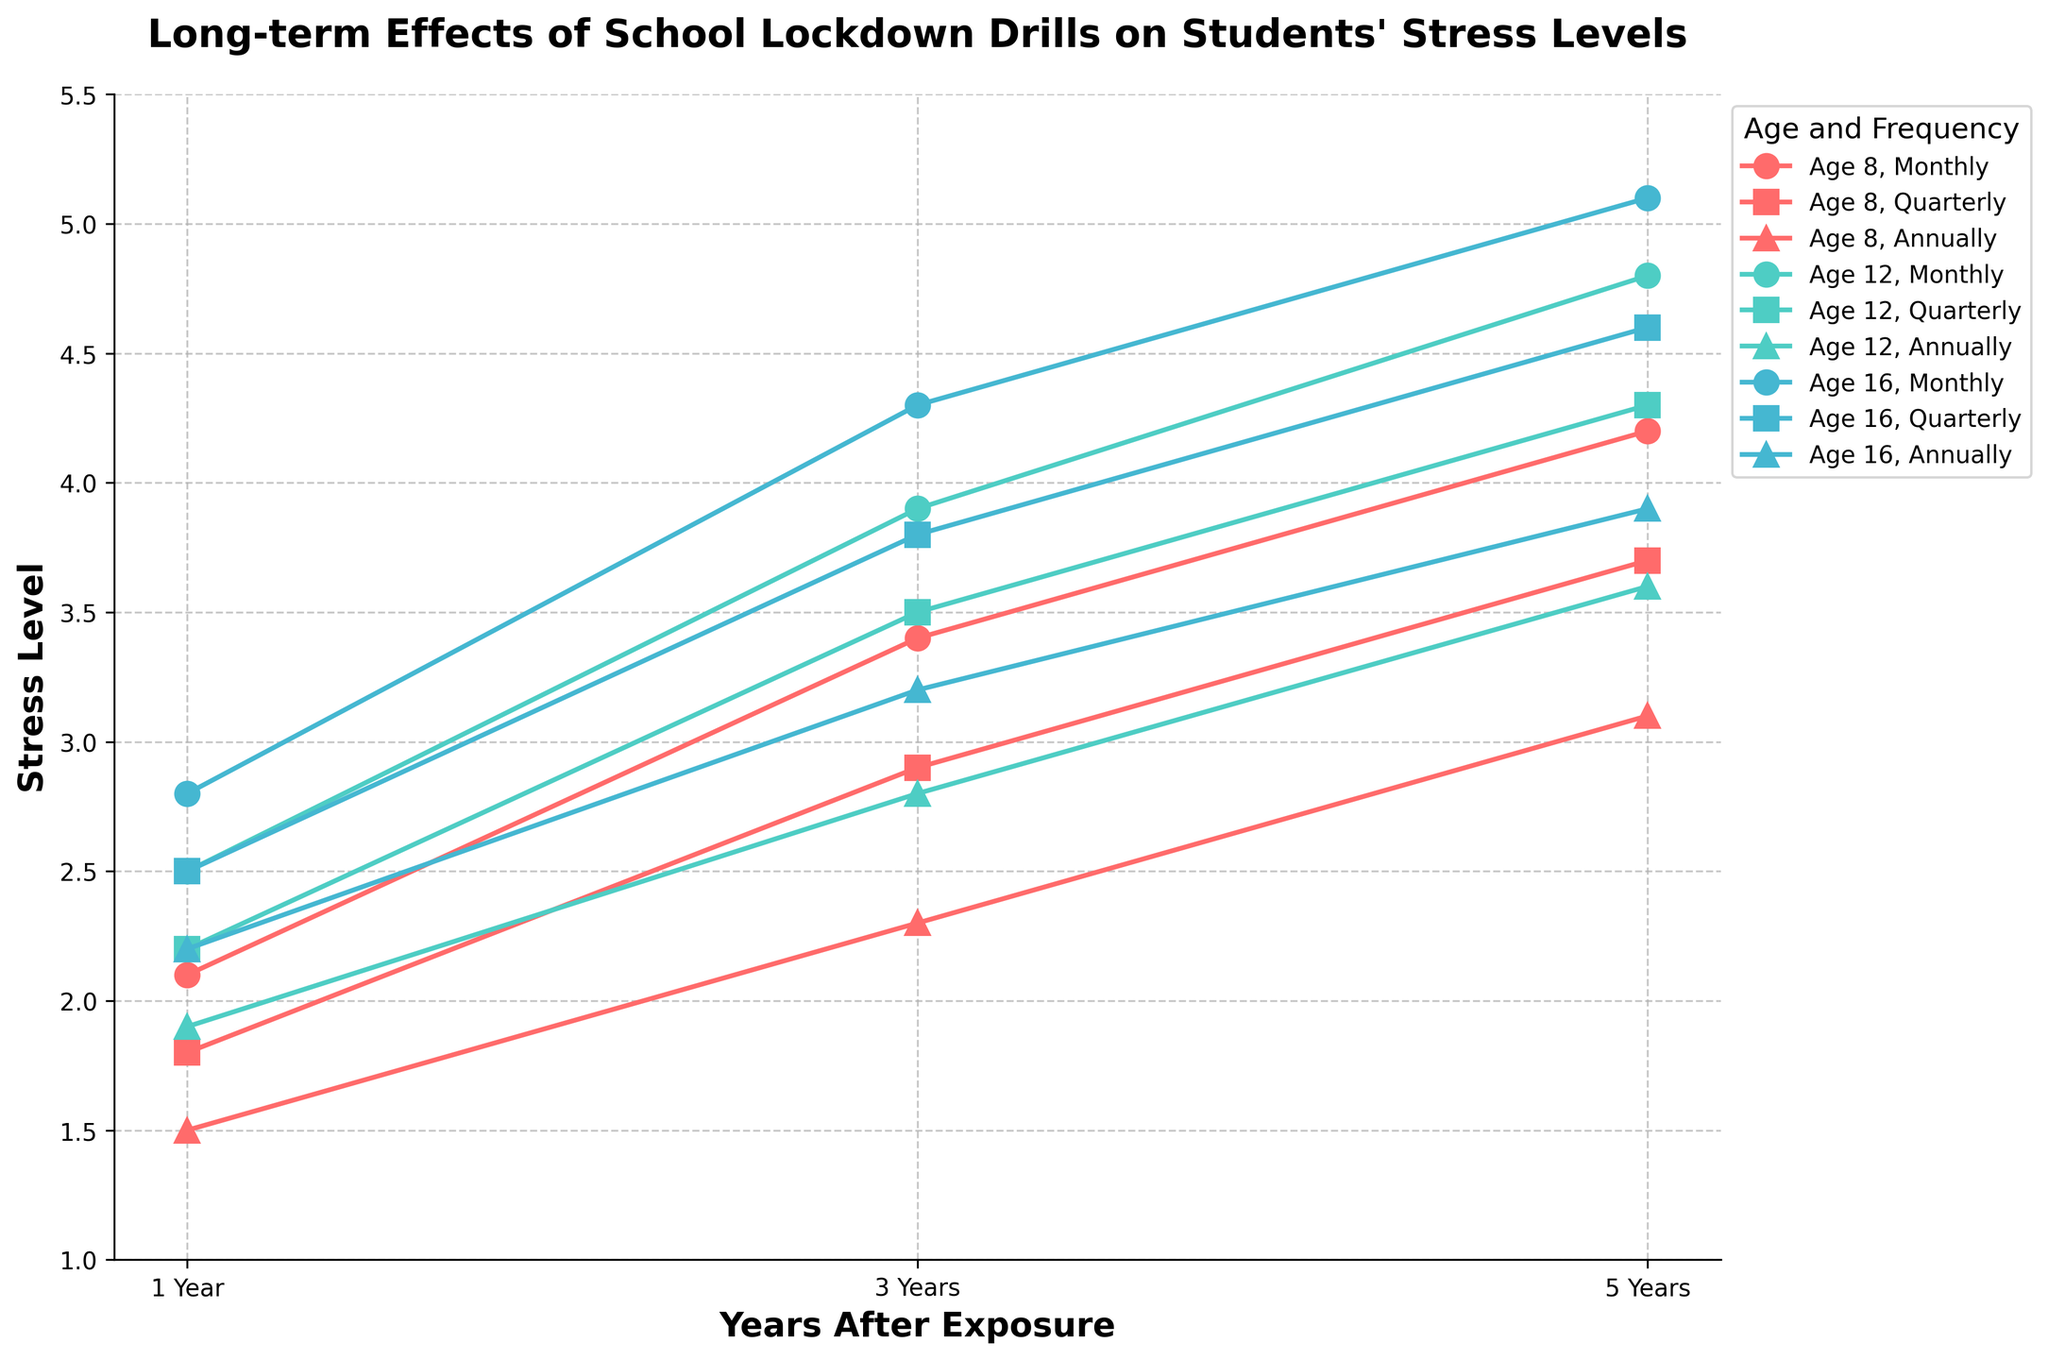What is the stress level for an 8-year-old student exposed to monthly drills after 1 year compared to 12-year-olds exposed to quarterly drills after 1 year? The stress level for an 8-year-old with monthly drills after 1 year is 2.1. For a 12-year-old with quarterly drills after 1 year, the stress level is 2.2. Comparing these, the 12-year-old has a slightly higher stress level.
Answer: 12-year-olds have a slightly higher stress level Which age group shows the highest stress level after 5 years when exposed to monthly drills? Looking at the "5 Years" column for "Monthly" frequency, the stress levels are 4.2 (8 years), 4.8 (12 years), and 5.1 (16 years). Hence, 16-year-olds have the highest stress level after 5 years with monthly drills.
Answer: 16-year-olds How does the stress level change over time for 8-year-olds exposed to annual drills? For 8-year-olds with annual drills, the stress levels are 1.5 after 1 year, 2.3 after 3 years, and 3.1 after 5 years. The stress level increases steadily over the years.
Answer: Increases steadily Which age group and frequency combination shows the lowest stress level after 3 years? Looking at the "3 Years" column, the combinations are: 3.4 (8 years, monthly), 2.9 (8 years, quarterly), 2.3 (8 years, annually), 3.9 (12 years, monthly), 3.5 (12 years, quarterly), 2.8 (12 years, annually), 4.3 (16 years, monthly), 3.8 (16 years, quarterly), 3.2 (16 years, annually). The lowest value is 2.3, for 8-year-olds with annual drills.
Answer: 8-year-olds with annual drills What is the difference in stress levels between 16-year-olds and 8-year-olds at the 5-year mark for quarterly drills? For the 5-year mark with quarterly drills, 16-year-olds have a stress level of 4.6, and 8-year-olds have a stress level of 3.7. The difference is 4.6 - 3.7 = 0.9.
Answer: 0.9 How does the stress level trend differ for an 8-year-old exposed to monthly drills and a 16-year-old exposed to annual drills? For an 8-year-old with monthly drills, the stress levels increase from 2.1 (1 year), to 3.4 (3 years), to 4.2 (5 years). For a 16-year-old with annual drills, the stress levels increase from 2.2 (1 year), to 3.2 (3 years), to 3.9 (5 years). The 8-year-old shows a steeper increase over time compared to the 16-year-old.
Answer: 8-year-old shows a steeper increase What is the average stress level for 12-year-olds exposed to quarterly drills over the 5-year period? The stress levels for 12-year-olds with quarterly drills are 2.2 after 1 year, 3.5 after 3 years, and 4.3 after 5 years. The average is calculated as (2.2 + 3.5 + 4.3)/3 = 10/3 = 3.33.
Answer: 3.33 